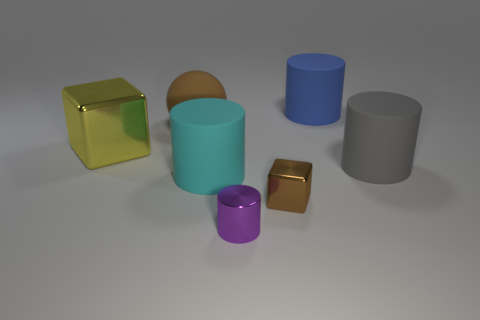Add 2 tiny things. How many objects exist? 9 Subtract all blocks. How many objects are left? 5 Add 1 small gray shiny objects. How many small gray shiny objects exist? 1 Subtract 0 purple blocks. How many objects are left? 7 Subtract all big green rubber balls. Subtract all purple metal objects. How many objects are left? 6 Add 2 large brown matte spheres. How many large brown matte spheres are left? 3 